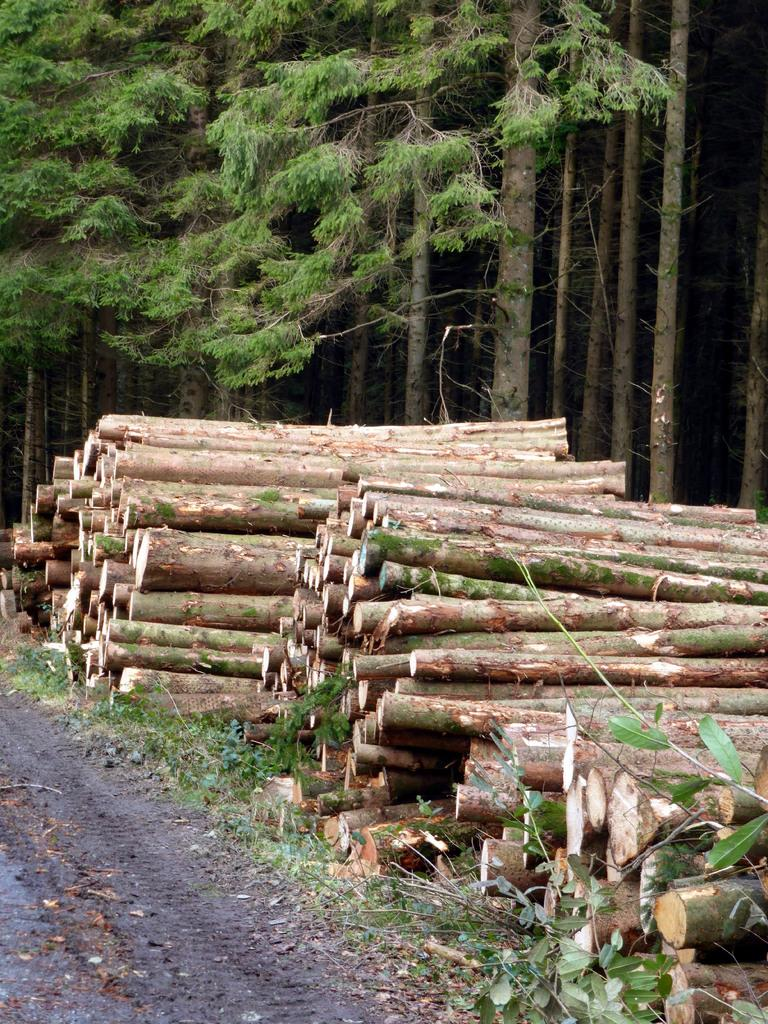What type of material are the logs made of in the image? The logs in the image are made of wood. Where are the wooden logs located in relation to the road? The wooden logs are placed beside the road. What can be seen in the background of the image? There are trees in the background of the image. What purpose does the notebook serve in the image? There is no notebook present in the image, so it cannot serve any purpose in this context. 